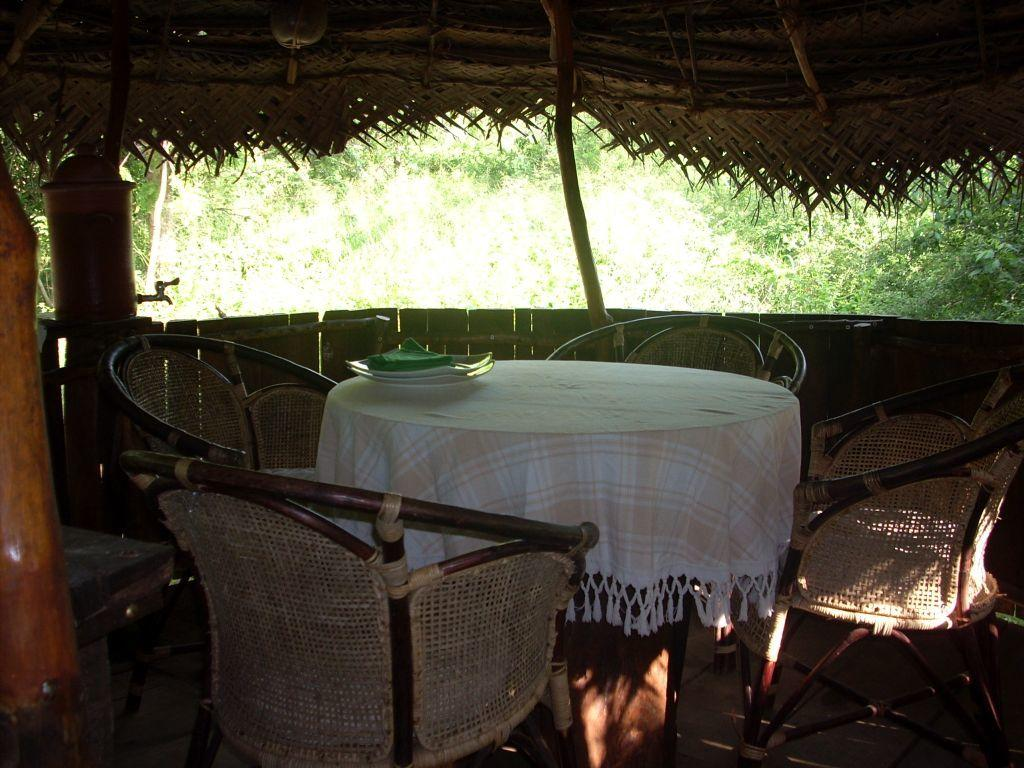What is covering the table in the image? There is a table with a cloth in the image. What objects are placed on the table? There are plates on the table. What type of furniture is present in the image? There are chairs in the image. What type of structure can be seen in the image? There is a hut in the image. What is the source of water in the image? There is a tap in the image. What can be seen in the background of the image? There are trees visible in the background of the image. What type of event is taking place in the image? There is no event taking place in the image; it is a scene featuring a table, chairs, a hut, and trees. Can you see a sail in the image? There is no sail present in the image. 